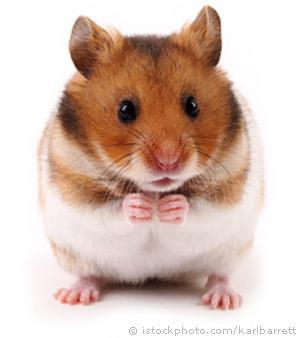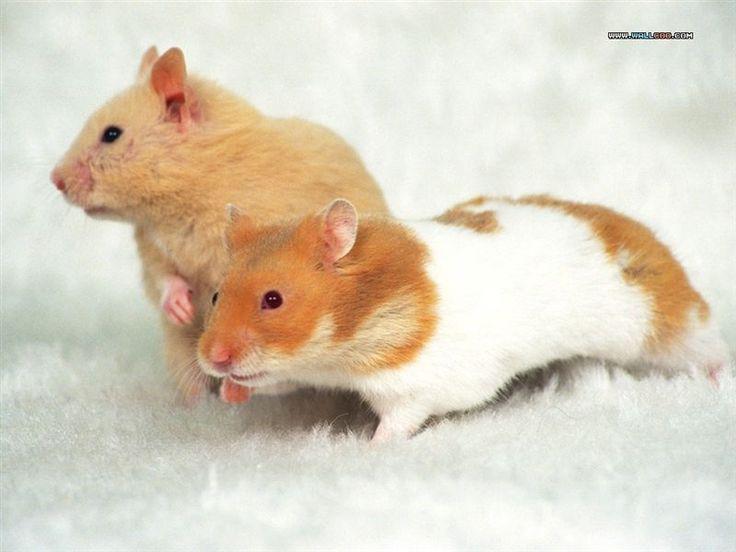The first image is the image on the left, the second image is the image on the right. For the images displayed, is the sentence "The single hamster in one of the images has three feet on the floor and the other raised." factually correct? Answer yes or no. No. 